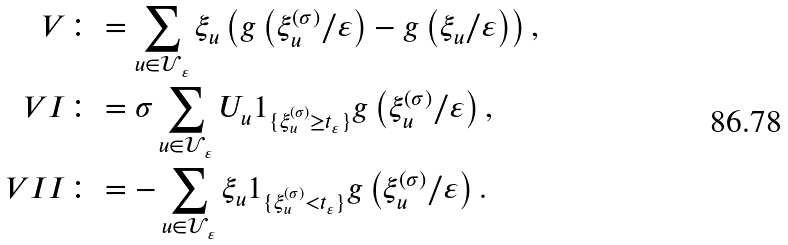Convert formula to latex. <formula><loc_0><loc_0><loc_500><loc_500>V & \colon = \sum _ { u \in { \mathcal { U } } _ { \, \varepsilon } } \xi _ { u } \left ( g \left ( \xi _ { u } ^ { ( \sigma ) } / \varepsilon \right ) - g \left ( \xi _ { u } / \varepsilon \right ) \right ) , \\ V I & \colon = \sigma \sum _ { u \in { \mathcal { U } } _ { \, \varepsilon } } U _ { u } 1 _ { \{ \xi _ { u } ^ { ( \sigma ) } \geq t _ { \varepsilon } \} } g \left ( \xi _ { u } ^ { ( \sigma ) } / \varepsilon \right ) , \\ V I I & \colon = - \sum _ { u \in { \mathcal { U } } _ { \, \varepsilon } } \xi _ { u } 1 _ { \{ \xi _ { u } ^ { ( \sigma ) } < t _ { \varepsilon } \} } g \left ( \xi _ { u } ^ { ( \sigma ) } / \varepsilon \right ) .</formula> 